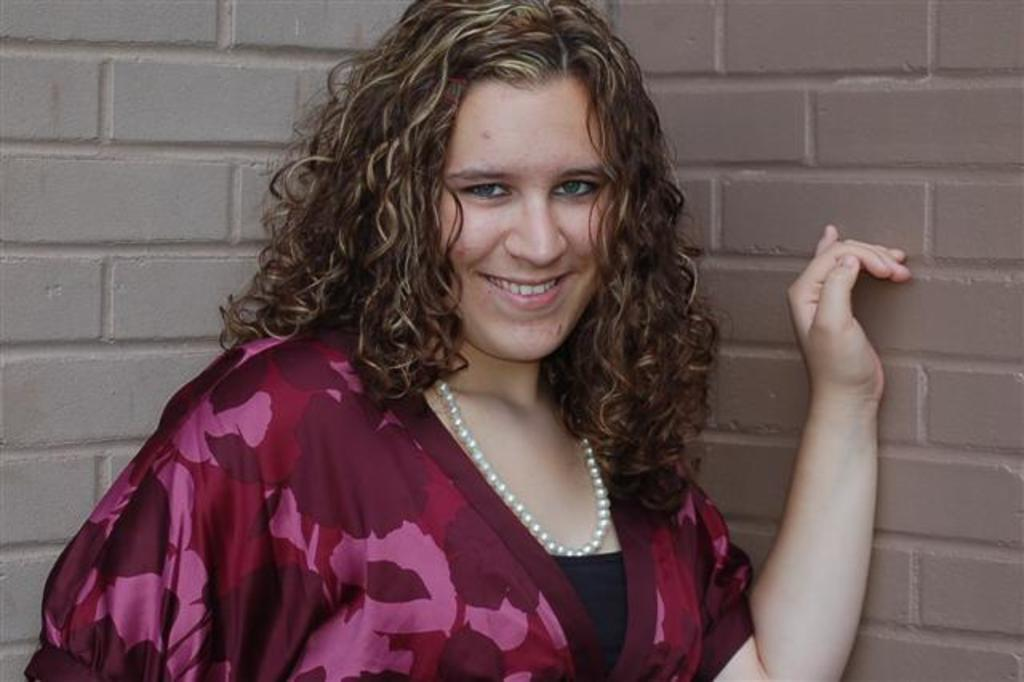Who is present in the image? There is a woman in the image. What is the woman's facial expression? The woman is smiling. What accessory is the woman wearing? The woman is wearing a necklace. What can be seen in the background of the image? There is a wall in the background of the image. Is the woman wearing a mask in the image? No, the woman is not wearing a mask in the image. Is the woman swimming in the image? No, the woman is not swimming in the image. 